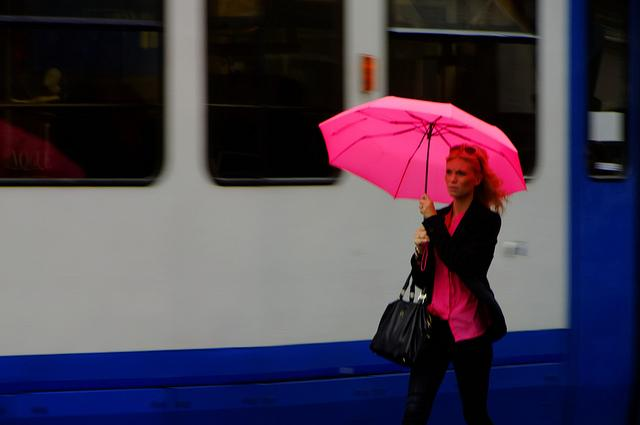Why does the woman use pink umbrella? Please explain your reasoning. match clothes. This woman has a fashion sense and wants to have her umbrella match her shirt. 